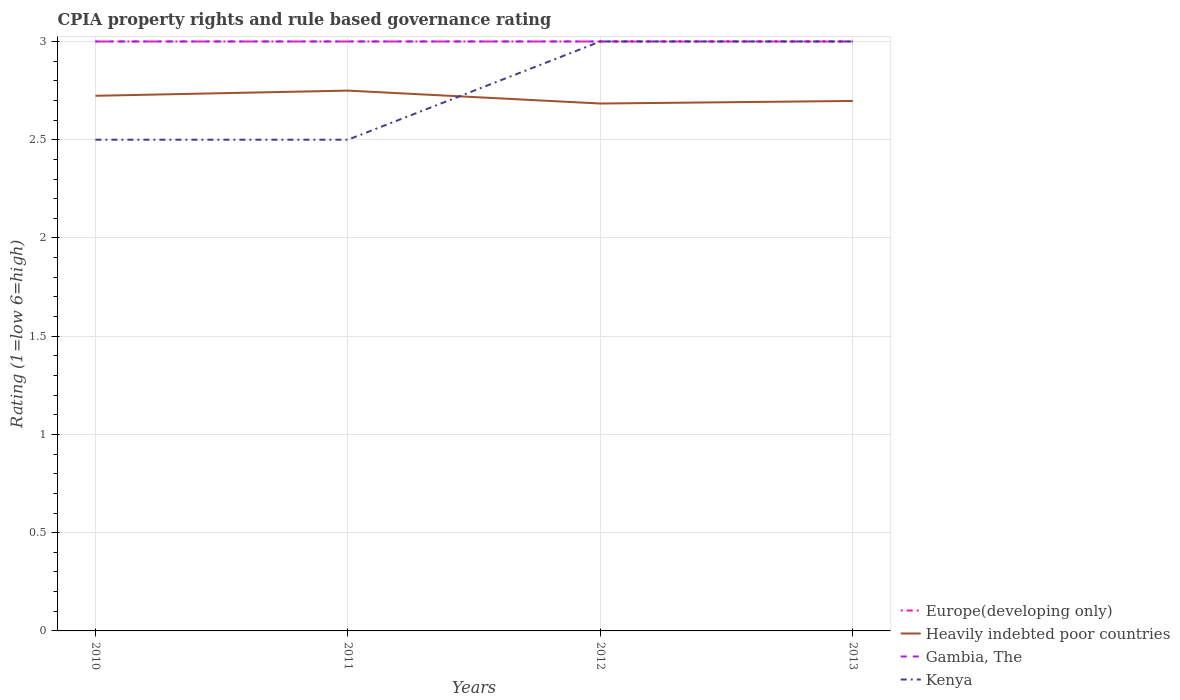How many different coloured lines are there?
Make the answer very short. 4. In which year was the CPIA rating in Europe(developing only) maximum?
Your answer should be compact. 2010. What is the difference between the highest and the second highest CPIA rating in Heavily indebted poor countries?
Your response must be concise. 0.07. Is the CPIA rating in Gambia, The strictly greater than the CPIA rating in Heavily indebted poor countries over the years?
Provide a short and direct response. No. How many lines are there?
Keep it short and to the point. 4. What is the difference between two consecutive major ticks on the Y-axis?
Provide a succinct answer. 0.5. Are the values on the major ticks of Y-axis written in scientific E-notation?
Your answer should be compact. No. Does the graph contain grids?
Give a very brief answer. Yes. Where does the legend appear in the graph?
Provide a succinct answer. Bottom right. How are the legend labels stacked?
Make the answer very short. Vertical. What is the title of the graph?
Give a very brief answer. CPIA property rights and rule based governance rating. Does "Central Europe" appear as one of the legend labels in the graph?
Keep it short and to the point. No. What is the label or title of the X-axis?
Ensure brevity in your answer.  Years. What is the label or title of the Y-axis?
Give a very brief answer. Rating (1=low 6=high). What is the Rating (1=low 6=high) of Heavily indebted poor countries in 2010?
Offer a terse response. 2.72. What is the Rating (1=low 6=high) of Gambia, The in 2010?
Ensure brevity in your answer.  3. What is the Rating (1=low 6=high) in Kenya in 2010?
Offer a very short reply. 2.5. What is the Rating (1=low 6=high) of Heavily indebted poor countries in 2011?
Provide a succinct answer. 2.75. What is the Rating (1=low 6=high) in Gambia, The in 2011?
Keep it short and to the point. 3. What is the Rating (1=low 6=high) in Heavily indebted poor countries in 2012?
Your response must be concise. 2.68. What is the Rating (1=low 6=high) in Gambia, The in 2012?
Ensure brevity in your answer.  3. What is the Rating (1=low 6=high) of Kenya in 2012?
Your answer should be compact. 3. What is the Rating (1=low 6=high) in Heavily indebted poor countries in 2013?
Make the answer very short. 2.7. Across all years, what is the maximum Rating (1=low 6=high) in Heavily indebted poor countries?
Your answer should be very brief. 2.75. Across all years, what is the minimum Rating (1=low 6=high) in Europe(developing only)?
Ensure brevity in your answer.  3. Across all years, what is the minimum Rating (1=low 6=high) in Heavily indebted poor countries?
Ensure brevity in your answer.  2.68. What is the total Rating (1=low 6=high) of Heavily indebted poor countries in the graph?
Provide a short and direct response. 10.86. What is the total Rating (1=low 6=high) of Gambia, The in the graph?
Your answer should be very brief. 12. What is the difference between the Rating (1=low 6=high) of Europe(developing only) in 2010 and that in 2011?
Provide a short and direct response. 0. What is the difference between the Rating (1=low 6=high) of Heavily indebted poor countries in 2010 and that in 2011?
Give a very brief answer. -0.03. What is the difference between the Rating (1=low 6=high) of Gambia, The in 2010 and that in 2011?
Offer a terse response. 0. What is the difference between the Rating (1=low 6=high) in Europe(developing only) in 2010 and that in 2012?
Offer a very short reply. 0. What is the difference between the Rating (1=low 6=high) in Heavily indebted poor countries in 2010 and that in 2012?
Your response must be concise. 0.04. What is the difference between the Rating (1=low 6=high) of Gambia, The in 2010 and that in 2012?
Your answer should be very brief. 0. What is the difference between the Rating (1=low 6=high) of Heavily indebted poor countries in 2010 and that in 2013?
Ensure brevity in your answer.  0.03. What is the difference between the Rating (1=low 6=high) of Gambia, The in 2010 and that in 2013?
Your response must be concise. 0. What is the difference between the Rating (1=low 6=high) of Europe(developing only) in 2011 and that in 2012?
Keep it short and to the point. 0. What is the difference between the Rating (1=low 6=high) in Heavily indebted poor countries in 2011 and that in 2012?
Ensure brevity in your answer.  0.07. What is the difference between the Rating (1=low 6=high) in Kenya in 2011 and that in 2012?
Provide a short and direct response. -0.5. What is the difference between the Rating (1=low 6=high) in Europe(developing only) in 2011 and that in 2013?
Your answer should be very brief. 0. What is the difference between the Rating (1=low 6=high) in Heavily indebted poor countries in 2011 and that in 2013?
Your answer should be compact. 0.05. What is the difference between the Rating (1=low 6=high) in Gambia, The in 2011 and that in 2013?
Provide a short and direct response. 0. What is the difference between the Rating (1=low 6=high) of Kenya in 2011 and that in 2013?
Your answer should be very brief. -0.5. What is the difference between the Rating (1=low 6=high) in Europe(developing only) in 2012 and that in 2013?
Your answer should be very brief. 0. What is the difference between the Rating (1=low 6=high) of Heavily indebted poor countries in 2012 and that in 2013?
Your answer should be compact. -0.01. What is the difference between the Rating (1=low 6=high) in Europe(developing only) in 2010 and the Rating (1=low 6=high) in Gambia, The in 2011?
Provide a short and direct response. 0. What is the difference between the Rating (1=low 6=high) of Europe(developing only) in 2010 and the Rating (1=low 6=high) of Kenya in 2011?
Your answer should be very brief. 0.5. What is the difference between the Rating (1=low 6=high) in Heavily indebted poor countries in 2010 and the Rating (1=low 6=high) in Gambia, The in 2011?
Keep it short and to the point. -0.28. What is the difference between the Rating (1=low 6=high) in Heavily indebted poor countries in 2010 and the Rating (1=low 6=high) in Kenya in 2011?
Give a very brief answer. 0.22. What is the difference between the Rating (1=low 6=high) of Gambia, The in 2010 and the Rating (1=low 6=high) of Kenya in 2011?
Give a very brief answer. 0.5. What is the difference between the Rating (1=low 6=high) in Europe(developing only) in 2010 and the Rating (1=low 6=high) in Heavily indebted poor countries in 2012?
Make the answer very short. 0.32. What is the difference between the Rating (1=low 6=high) of Heavily indebted poor countries in 2010 and the Rating (1=low 6=high) of Gambia, The in 2012?
Keep it short and to the point. -0.28. What is the difference between the Rating (1=low 6=high) of Heavily indebted poor countries in 2010 and the Rating (1=low 6=high) of Kenya in 2012?
Offer a very short reply. -0.28. What is the difference between the Rating (1=low 6=high) in Gambia, The in 2010 and the Rating (1=low 6=high) in Kenya in 2012?
Offer a very short reply. 0. What is the difference between the Rating (1=low 6=high) of Europe(developing only) in 2010 and the Rating (1=low 6=high) of Heavily indebted poor countries in 2013?
Make the answer very short. 0.3. What is the difference between the Rating (1=low 6=high) in Heavily indebted poor countries in 2010 and the Rating (1=low 6=high) in Gambia, The in 2013?
Provide a short and direct response. -0.28. What is the difference between the Rating (1=low 6=high) in Heavily indebted poor countries in 2010 and the Rating (1=low 6=high) in Kenya in 2013?
Give a very brief answer. -0.28. What is the difference between the Rating (1=low 6=high) in Europe(developing only) in 2011 and the Rating (1=low 6=high) in Heavily indebted poor countries in 2012?
Your answer should be compact. 0.32. What is the difference between the Rating (1=low 6=high) of Europe(developing only) in 2011 and the Rating (1=low 6=high) of Kenya in 2012?
Your response must be concise. 0. What is the difference between the Rating (1=low 6=high) of Heavily indebted poor countries in 2011 and the Rating (1=low 6=high) of Gambia, The in 2012?
Provide a succinct answer. -0.25. What is the difference between the Rating (1=low 6=high) of Heavily indebted poor countries in 2011 and the Rating (1=low 6=high) of Kenya in 2012?
Your answer should be compact. -0.25. What is the difference between the Rating (1=low 6=high) of Gambia, The in 2011 and the Rating (1=low 6=high) of Kenya in 2012?
Your response must be concise. 0. What is the difference between the Rating (1=low 6=high) in Europe(developing only) in 2011 and the Rating (1=low 6=high) in Heavily indebted poor countries in 2013?
Ensure brevity in your answer.  0.3. What is the difference between the Rating (1=low 6=high) in Europe(developing only) in 2011 and the Rating (1=low 6=high) in Gambia, The in 2013?
Provide a short and direct response. 0. What is the difference between the Rating (1=low 6=high) in Gambia, The in 2011 and the Rating (1=low 6=high) in Kenya in 2013?
Your answer should be very brief. 0. What is the difference between the Rating (1=low 6=high) of Europe(developing only) in 2012 and the Rating (1=low 6=high) of Heavily indebted poor countries in 2013?
Give a very brief answer. 0.3. What is the difference between the Rating (1=low 6=high) in Europe(developing only) in 2012 and the Rating (1=low 6=high) in Gambia, The in 2013?
Provide a short and direct response. 0. What is the difference between the Rating (1=low 6=high) of Heavily indebted poor countries in 2012 and the Rating (1=low 6=high) of Gambia, The in 2013?
Give a very brief answer. -0.32. What is the difference between the Rating (1=low 6=high) in Heavily indebted poor countries in 2012 and the Rating (1=low 6=high) in Kenya in 2013?
Give a very brief answer. -0.32. What is the difference between the Rating (1=low 6=high) in Gambia, The in 2012 and the Rating (1=low 6=high) in Kenya in 2013?
Keep it short and to the point. 0. What is the average Rating (1=low 6=high) in Europe(developing only) per year?
Give a very brief answer. 3. What is the average Rating (1=low 6=high) in Heavily indebted poor countries per year?
Provide a short and direct response. 2.71. What is the average Rating (1=low 6=high) in Kenya per year?
Give a very brief answer. 2.75. In the year 2010, what is the difference between the Rating (1=low 6=high) in Europe(developing only) and Rating (1=low 6=high) in Heavily indebted poor countries?
Your answer should be very brief. 0.28. In the year 2010, what is the difference between the Rating (1=low 6=high) of Europe(developing only) and Rating (1=low 6=high) of Gambia, The?
Offer a terse response. 0. In the year 2010, what is the difference between the Rating (1=low 6=high) of Heavily indebted poor countries and Rating (1=low 6=high) of Gambia, The?
Your response must be concise. -0.28. In the year 2010, what is the difference between the Rating (1=low 6=high) of Heavily indebted poor countries and Rating (1=low 6=high) of Kenya?
Ensure brevity in your answer.  0.22. In the year 2011, what is the difference between the Rating (1=low 6=high) in Europe(developing only) and Rating (1=low 6=high) in Heavily indebted poor countries?
Provide a succinct answer. 0.25. In the year 2011, what is the difference between the Rating (1=low 6=high) of Europe(developing only) and Rating (1=low 6=high) of Kenya?
Offer a very short reply. 0.5. In the year 2011, what is the difference between the Rating (1=low 6=high) in Gambia, The and Rating (1=low 6=high) in Kenya?
Offer a terse response. 0.5. In the year 2012, what is the difference between the Rating (1=low 6=high) in Europe(developing only) and Rating (1=low 6=high) in Heavily indebted poor countries?
Provide a short and direct response. 0.32. In the year 2012, what is the difference between the Rating (1=low 6=high) in Europe(developing only) and Rating (1=low 6=high) in Gambia, The?
Your response must be concise. 0. In the year 2012, what is the difference between the Rating (1=low 6=high) in Heavily indebted poor countries and Rating (1=low 6=high) in Gambia, The?
Provide a succinct answer. -0.32. In the year 2012, what is the difference between the Rating (1=low 6=high) in Heavily indebted poor countries and Rating (1=low 6=high) in Kenya?
Your response must be concise. -0.32. In the year 2012, what is the difference between the Rating (1=low 6=high) of Gambia, The and Rating (1=low 6=high) of Kenya?
Keep it short and to the point. 0. In the year 2013, what is the difference between the Rating (1=low 6=high) of Europe(developing only) and Rating (1=low 6=high) of Heavily indebted poor countries?
Provide a succinct answer. 0.3. In the year 2013, what is the difference between the Rating (1=low 6=high) in Europe(developing only) and Rating (1=low 6=high) in Gambia, The?
Make the answer very short. 0. In the year 2013, what is the difference between the Rating (1=low 6=high) of Europe(developing only) and Rating (1=low 6=high) of Kenya?
Your answer should be compact. 0. In the year 2013, what is the difference between the Rating (1=low 6=high) of Heavily indebted poor countries and Rating (1=low 6=high) of Gambia, The?
Make the answer very short. -0.3. In the year 2013, what is the difference between the Rating (1=low 6=high) of Heavily indebted poor countries and Rating (1=low 6=high) of Kenya?
Your answer should be very brief. -0.3. In the year 2013, what is the difference between the Rating (1=low 6=high) of Gambia, The and Rating (1=low 6=high) of Kenya?
Give a very brief answer. 0. What is the ratio of the Rating (1=low 6=high) of Europe(developing only) in 2010 to that in 2011?
Keep it short and to the point. 1. What is the ratio of the Rating (1=low 6=high) in Gambia, The in 2010 to that in 2011?
Your answer should be very brief. 1. What is the ratio of the Rating (1=low 6=high) in Heavily indebted poor countries in 2010 to that in 2012?
Provide a short and direct response. 1.01. What is the ratio of the Rating (1=low 6=high) of Heavily indebted poor countries in 2010 to that in 2013?
Offer a terse response. 1.01. What is the ratio of the Rating (1=low 6=high) in Heavily indebted poor countries in 2011 to that in 2012?
Give a very brief answer. 1.02. What is the ratio of the Rating (1=low 6=high) in Heavily indebted poor countries in 2011 to that in 2013?
Your answer should be very brief. 1.02. What is the ratio of the Rating (1=low 6=high) of Gambia, The in 2011 to that in 2013?
Your answer should be very brief. 1. What is the ratio of the Rating (1=low 6=high) in Kenya in 2011 to that in 2013?
Keep it short and to the point. 0.83. What is the ratio of the Rating (1=low 6=high) of Gambia, The in 2012 to that in 2013?
Ensure brevity in your answer.  1. What is the ratio of the Rating (1=low 6=high) of Kenya in 2012 to that in 2013?
Provide a succinct answer. 1. What is the difference between the highest and the second highest Rating (1=low 6=high) in Europe(developing only)?
Keep it short and to the point. 0. What is the difference between the highest and the second highest Rating (1=low 6=high) of Heavily indebted poor countries?
Provide a succinct answer. 0.03. What is the difference between the highest and the second highest Rating (1=low 6=high) of Kenya?
Offer a very short reply. 0. What is the difference between the highest and the lowest Rating (1=low 6=high) of Europe(developing only)?
Offer a very short reply. 0. What is the difference between the highest and the lowest Rating (1=low 6=high) in Heavily indebted poor countries?
Offer a very short reply. 0.07. What is the difference between the highest and the lowest Rating (1=low 6=high) in Kenya?
Offer a very short reply. 0.5. 